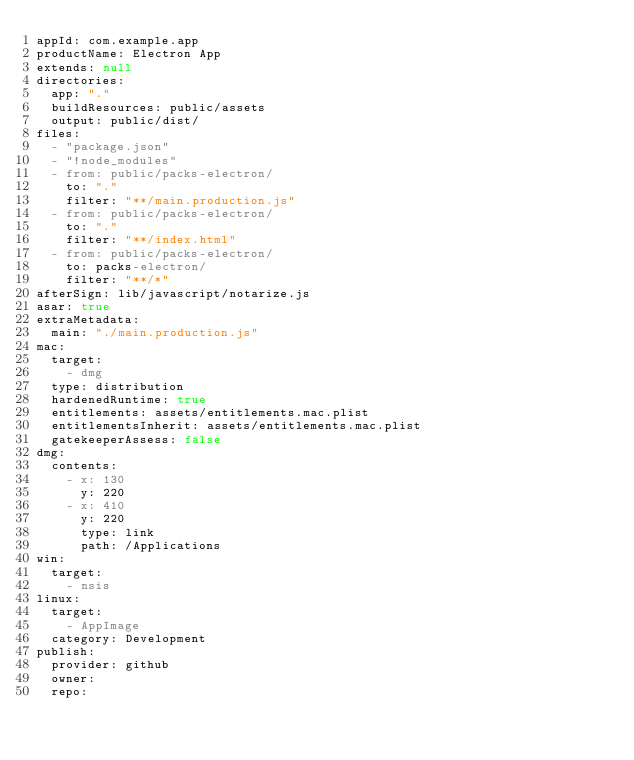Convert code to text. <code><loc_0><loc_0><loc_500><loc_500><_YAML_>appId: com.example.app
productName: Electron App
extends: null
directories:
  app: "."
  buildResources: public/assets
  output: public/dist/
files:
  - "package.json"
  - "!node_modules"
  - from: public/packs-electron/
    to: "."
    filter: "**/main.production.js"
  - from: public/packs-electron/
    to: "."
    filter: "**/index.html"
  - from: public/packs-electron/
    to: packs-electron/
    filter: "**/*"
afterSign: lib/javascript/notarize.js
asar: true
extraMetadata:
  main: "./main.production.js"
mac:
  target:
    - dmg
  type: distribution
  hardenedRuntime: true
  entitlements: assets/entitlements.mac.plist
  entitlementsInherit: assets/entitlements.mac.plist
  gatekeeperAssess: false
dmg:
  contents:
    - x: 130
      y: 220
    - x: 410
      y: 220
      type: link
      path: /Applications
win:
  target:
    - nsis
linux:
  target:
    - AppImage
  category: Development
publish:
  provider: github
  owner:
  repo:</code> 